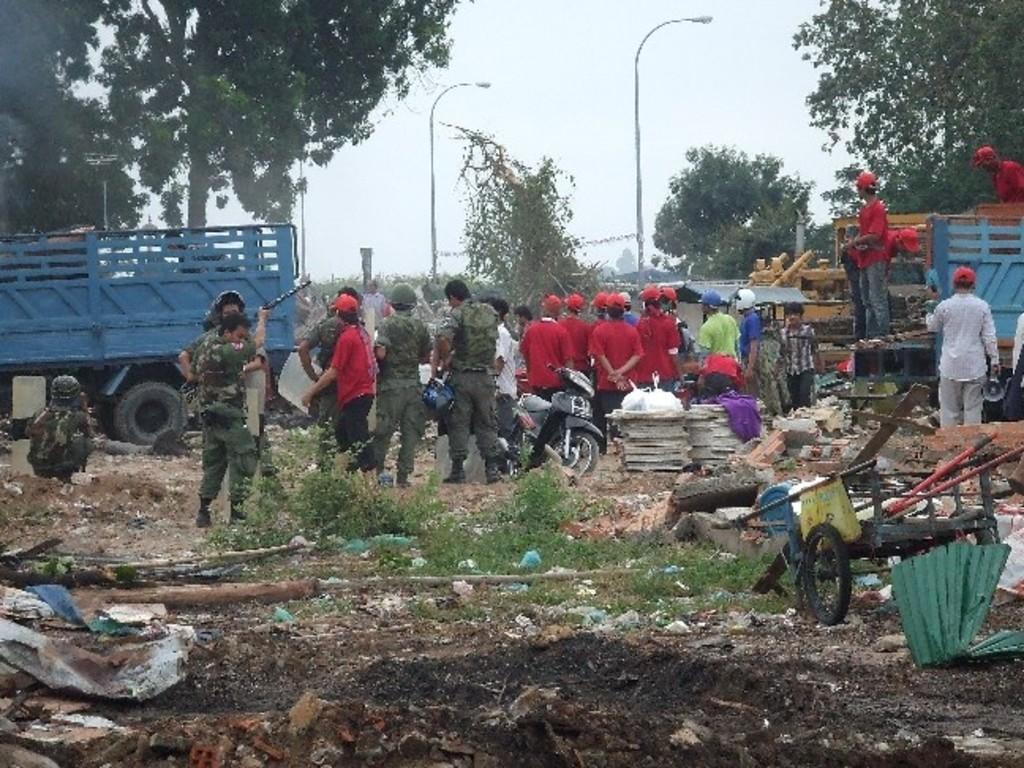Please provide a concise description of this image. In this image we can see group of people standing on the ground. Some people are wearing military uniforms. In the center of the image we can see a motorcycle. In the background, we can see group of vehicles parked on the ground , group of trees , light poles and the sky. 